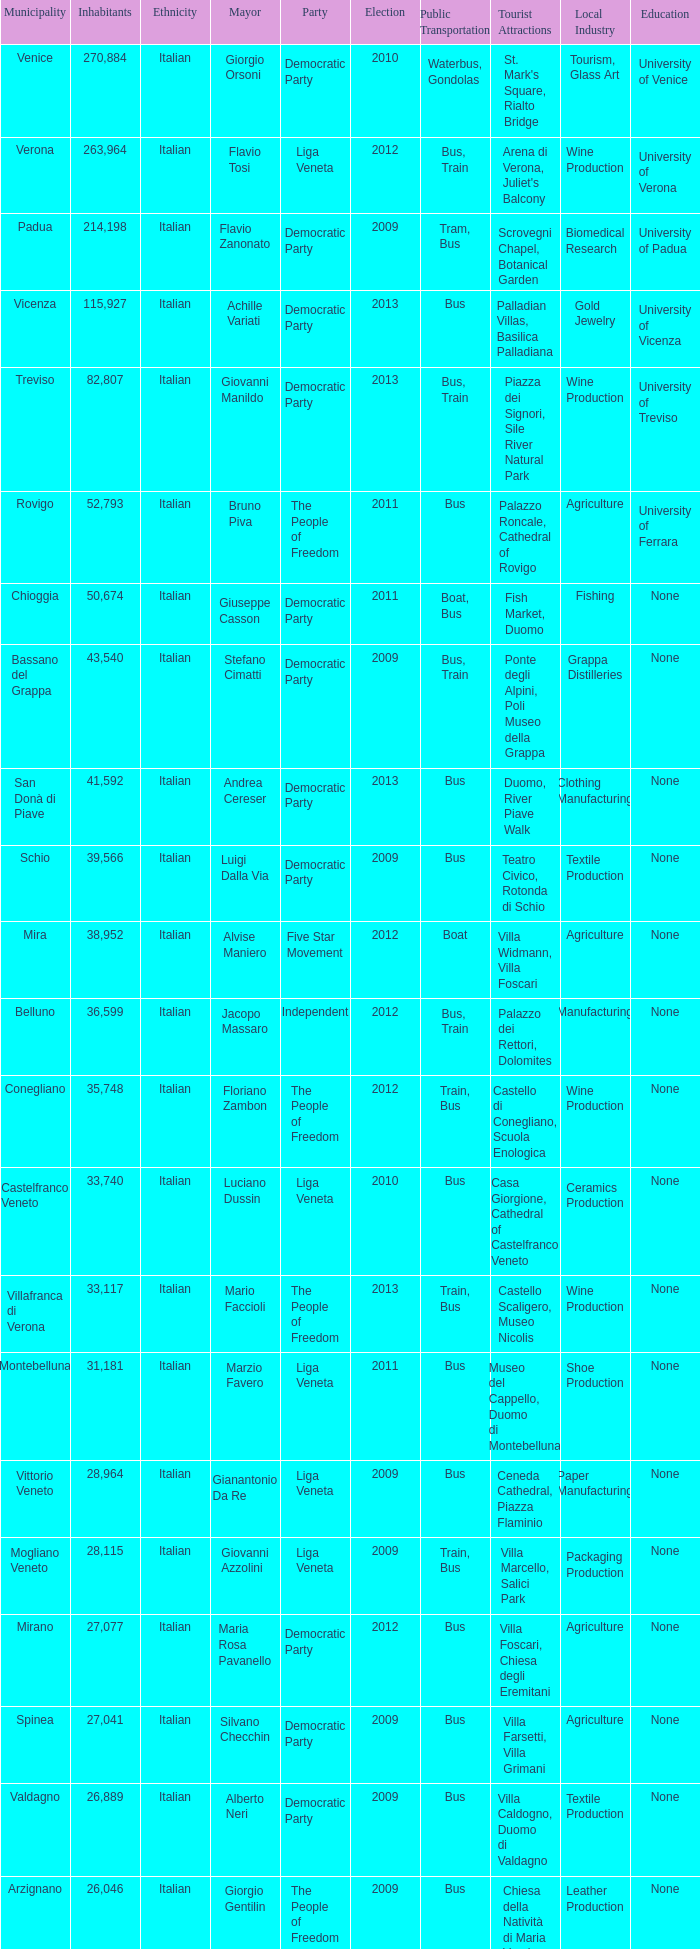How many Inhabitants were in the democratic party for an election before 2009 for Mayor of stefano cimatti? 0.0. 